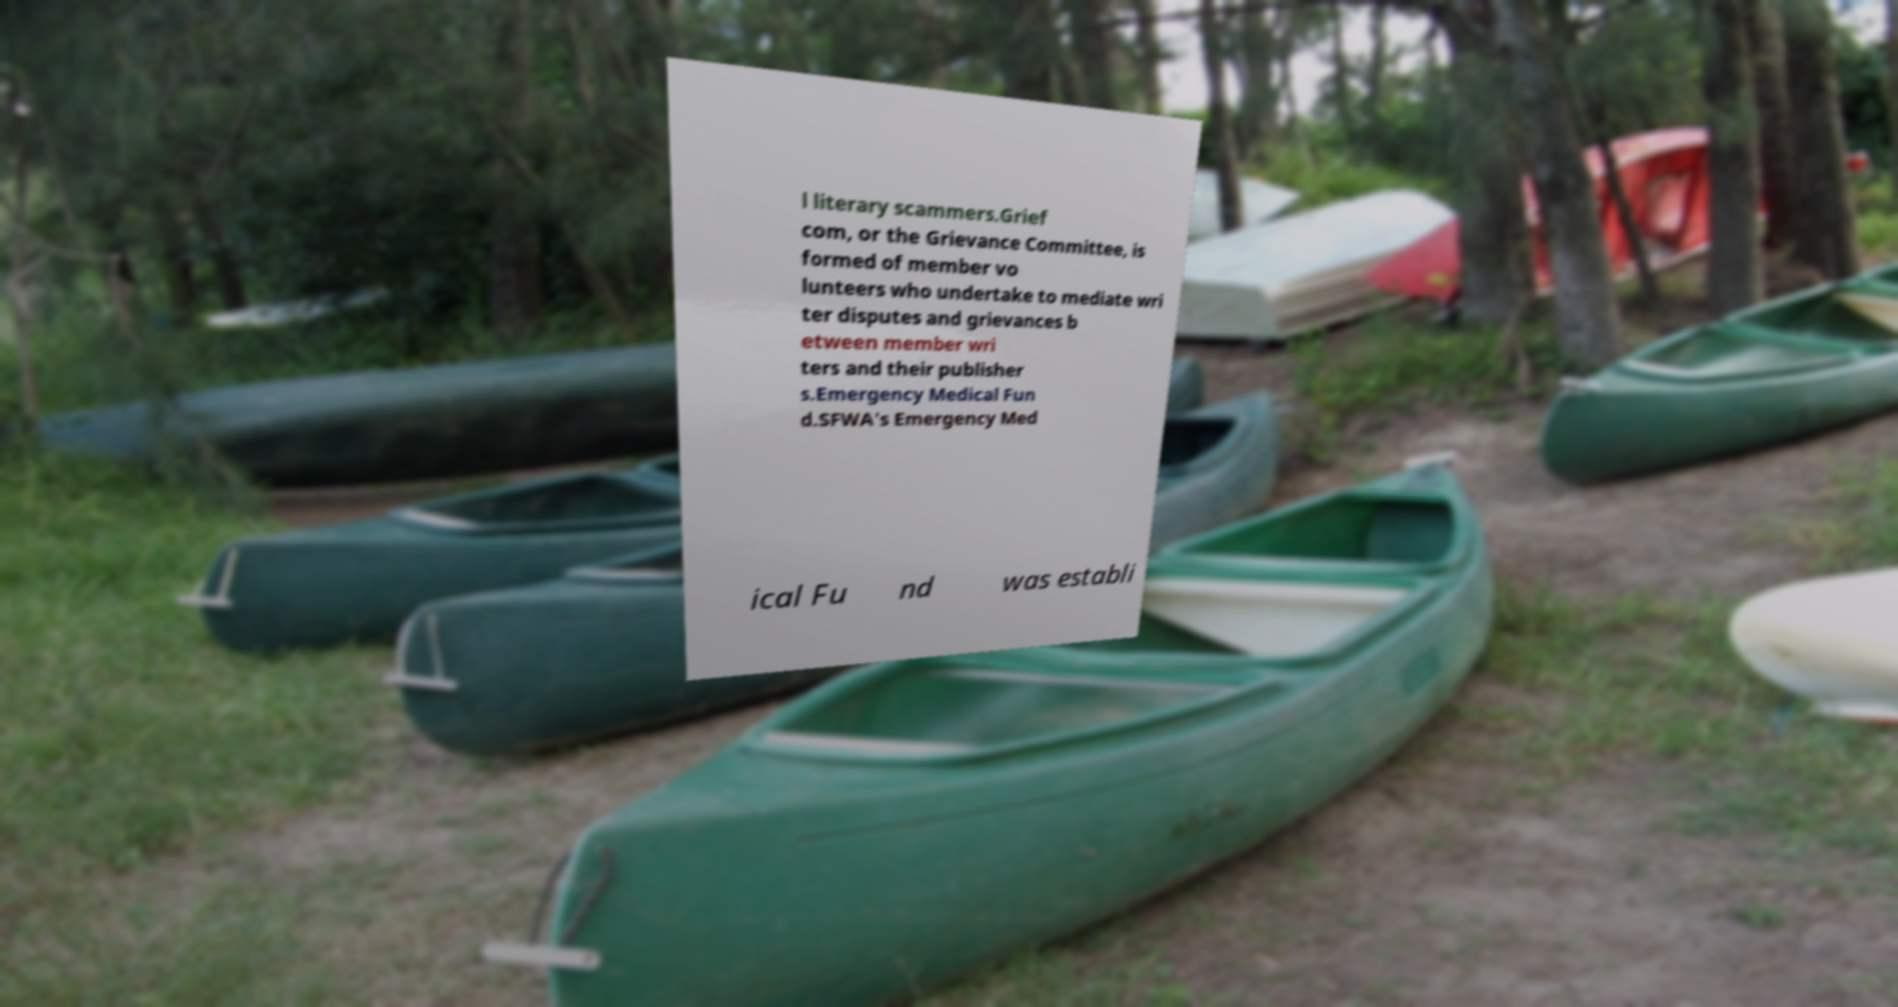Please identify and transcribe the text found in this image. l literary scammers.Grief com, or the Grievance Committee, is formed of member vo lunteers who undertake to mediate wri ter disputes and grievances b etween member wri ters and their publisher s.Emergency Medical Fun d.SFWA's Emergency Med ical Fu nd was establi 